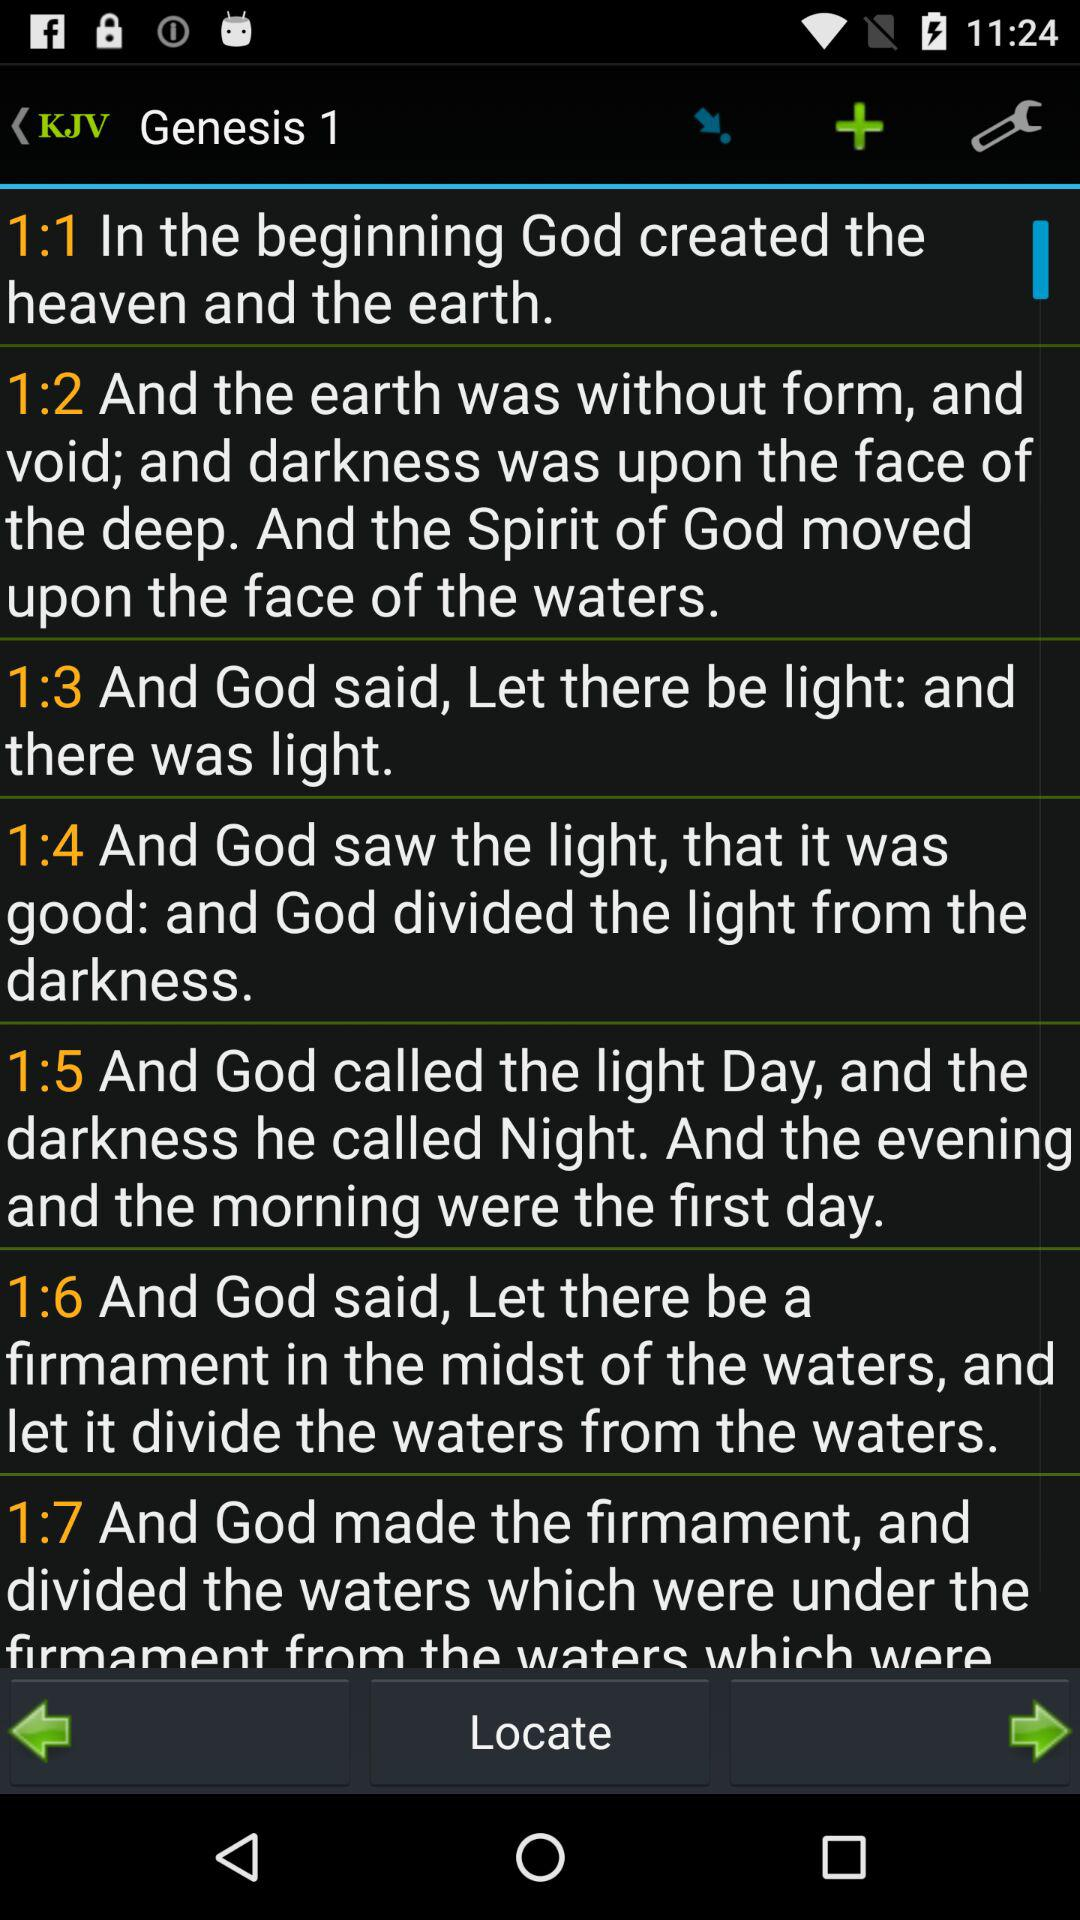What the God called the darkness? The God called the darkness "Night". 